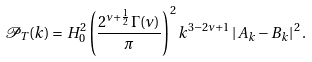<formula> <loc_0><loc_0><loc_500><loc_500>\mathcal { P } _ { T } ( k ) = H ^ { 2 } _ { 0 } \left ( \frac { 2 ^ { \nu + \frac { 1 } { 2 } } \Gamma ( \nu ) } { \pi } \right ) ^ { 2 } k ^ { 3 - 2 \nu + 1 } \left | A _ { k } - B _ { k } \right | ^ { 2 } .</formula> 